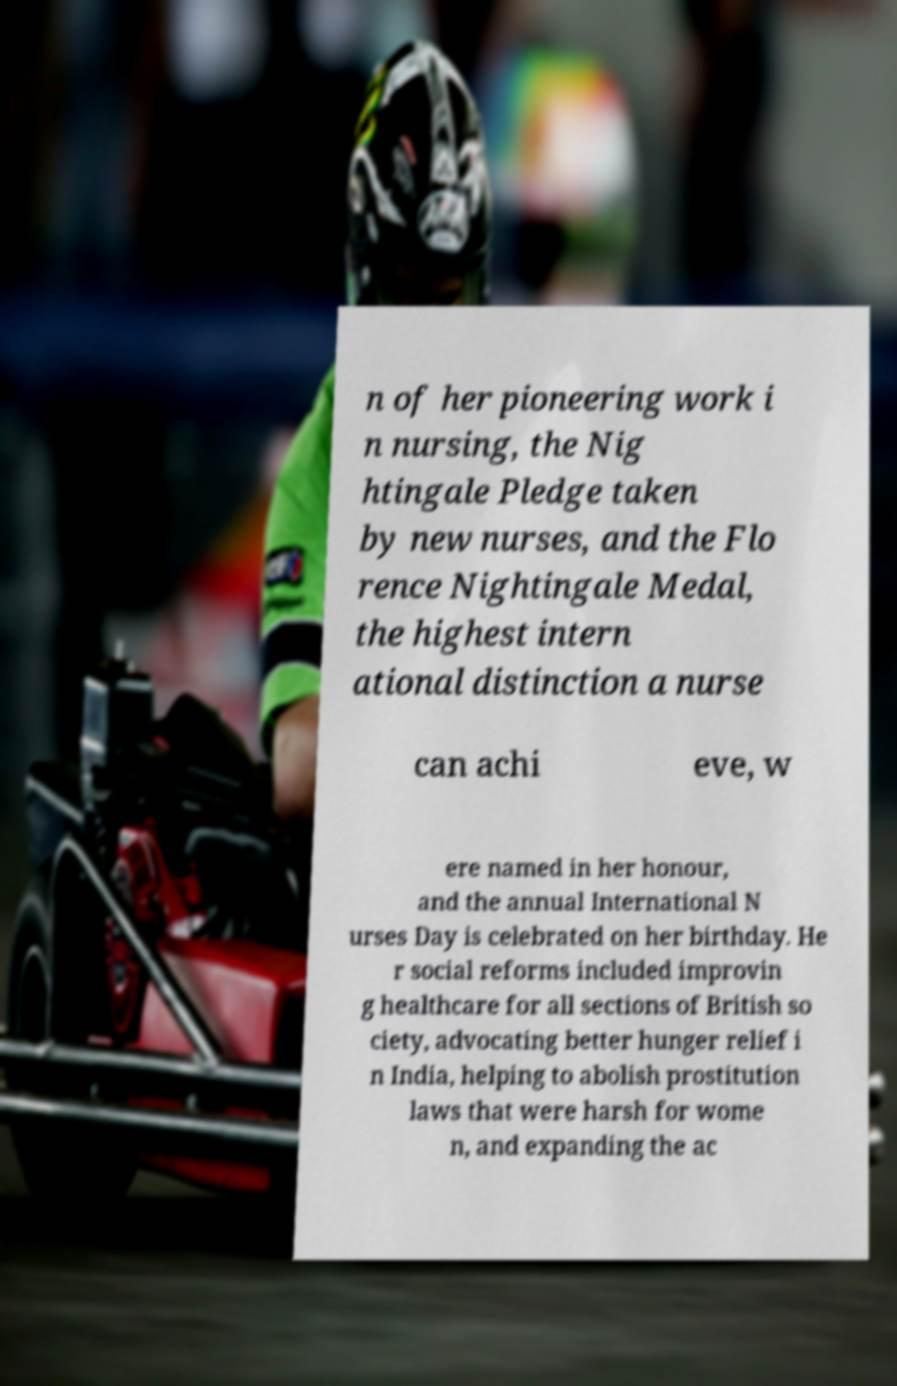Please identify and transcribe the text found in this image. n of her pioneering work i n nursing, the Nig htingale Pledge taken by new nurses, and the Flo rence Nightingale Medal, the highest intern ational distinction a nurse can achi eve, w ere named in her honour, and the annual International N urses Day is celebrated on her birthday. He r social reforms included improvin g healthcare for all sections of British so ciety, advocating better hunger relief i n India, helping to abolish prostitution laws that were harsh for wome n, and expanding the ac 